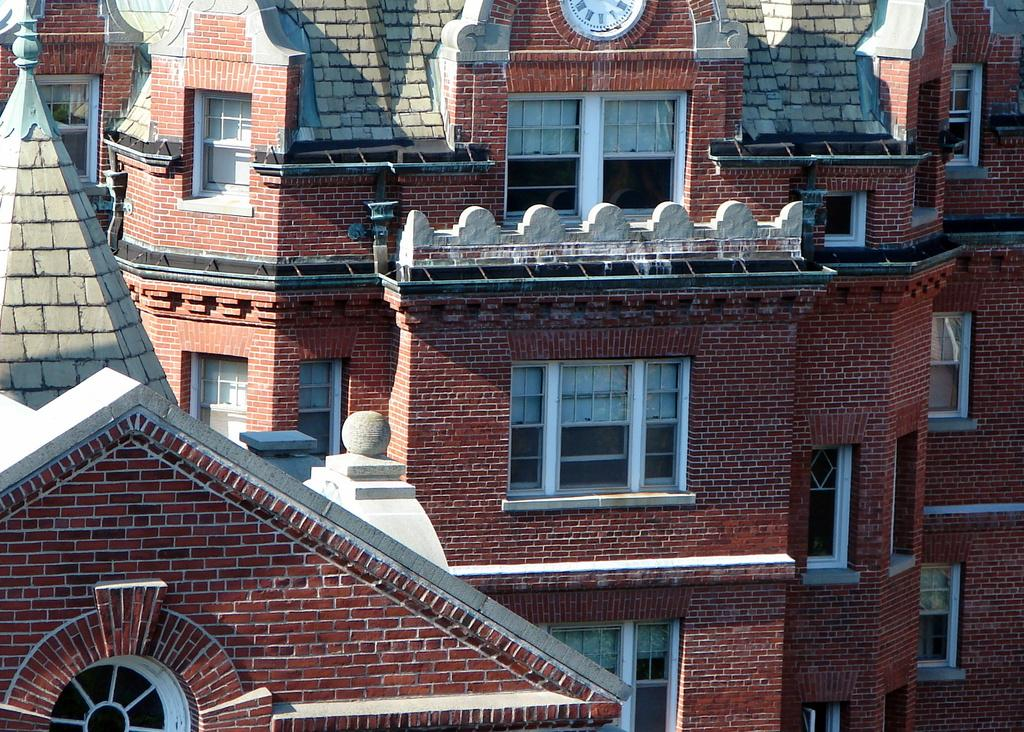What is the color of the building in the image? The building in the image is red. What architectural features can be seen on the building? Windows are visible on the wall of the building. What structure is located on the left side of the image? There is a tower visible on the left side of the image. What time-telling device is visible at the top of the image? A clock is visible at the top of the image. Can you see a yak grazing in front of the building in the image? No, there is no yak present in the image. 